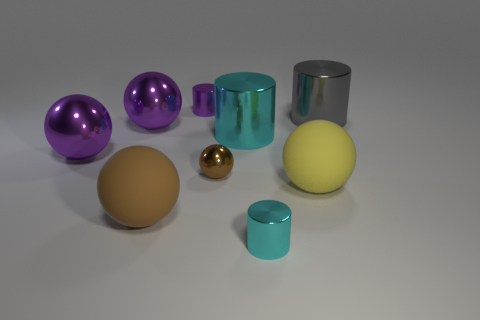Is the size of the sphere in front of the yellow ball the same as the purple cylinder?
Offer a very short reply. No. How many rubber balls are there?
Your answer should be very brief. 2. What number of spheres are big purple metal objects or big gray things?
Offer a terse response. 2. How many balls are left of the large metallic cylinder in front of the gray shiny cylinder?
Your answer should be compact. 4. Does the large cyan cylinder have the same material as the tiny cyan thing?
Provide a short and direct response. Yes. What size is the object that is the same color as the small sphere?
Provide a short and direct response. Large. Is there a yellow cylinder that has the same material as the large gray cylinder?
Keep it short and to the point. No. What is the color of the rubber sphere that is to the left of the large yellow rubber sphere on the right side of the cyan metallic cylinder in front of the big yellow ball?
Provide a short and direct response. Brown. What number of purple objects are either tiny metallic objects or tiny cylinders?
Give a very brief answer. 1. What number of purple things are the same shape as the yellow rubber object?
Give a very brief answer. 2. 